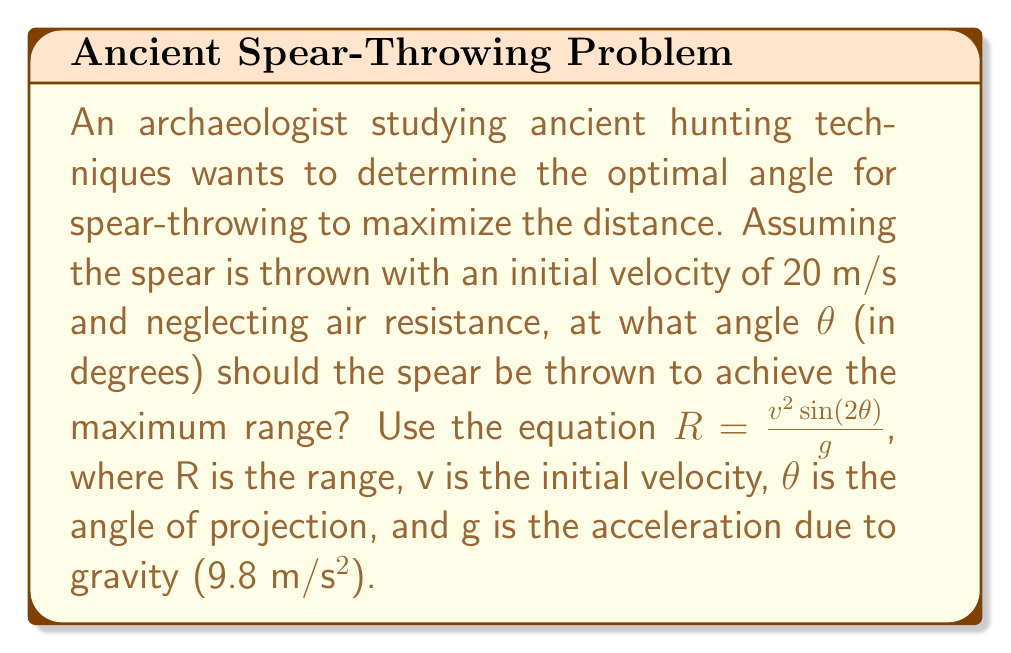Can you answer this question? 1) The range equation is given by:
   $$R = \frac{v^2 \sin(2\theta)}{g}$$

2) To find the maximum range, we need to maximize $\sin(2\theta)$. The maximum value of sine is 1, which occurs when its argument is 90°.

3) Therefore, for maximum range:
   $$2\theta = 90°$$

4) Solving for θ:
   $$\theta = 45°$$

5) We can verify this by calculating the range for angles slightly above and below 45°:

   For θ = 44°:
   $$R = \frac{20^2 \sin(2(44°))}{9.8} \approx 40.82\text{ m}$$

   For θ = 45°:
   $$R = \frac{20^2 \sin(2(45°))}{9.8} = \frac{400 \cdot 1}{9.8} \approx 40.82\text{ m}$$

   For θ = 46°:
   $$R = \frac{20^2 \sin(2(46°))}{9.8} \approx 40.81\text{ m}$$

6) The range is indeed maximum at 45°.
Answer: 45° 